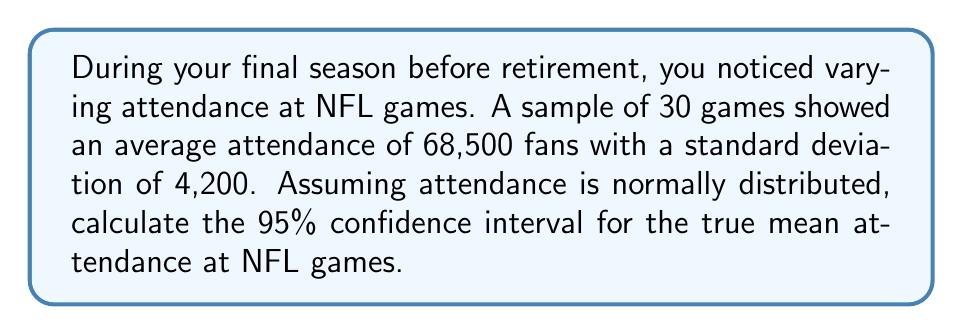What is the answer to this math problem? Let's approach this step-by-step:

1) We're given:
   - Sample size: $n = 30$
   - Sample mean: $\bar{x} = 68,500$
   - Sample standard deviation: $s = 4,200$
   - Confidence level: 95%

2) For a 95% confidence interval, we use a z-score of 1.96 (assuming a large sample size).

3) The formula for the confidence interval is:

   $$\bar{x} \pm z \cdot \frac{s}{\sqrt{n}}$$

4) Let's calculate the standard error:

   $$\frac{s}{\sqrt{n}} = \frac{4,200}{\sqrt{30}} \approx 766.81$$

5) Now, let's multiply this by our z-score:

   $$1.96 \cdot 766.81 \approx 1,502.95$$

6) Finally, we can calculate our confidence interval:

   Lower bound: $68,500 - 1,502.95 = 66,997.05$
   Upper bound: $68,500 + 1,502.95 = 70,002.95$

7) Rounding to the nearest whole number (as we can't have fractional attendees):

   The 95% confidence interval is (66,997, 70,003).
Answer: (66,997, 70,003) 